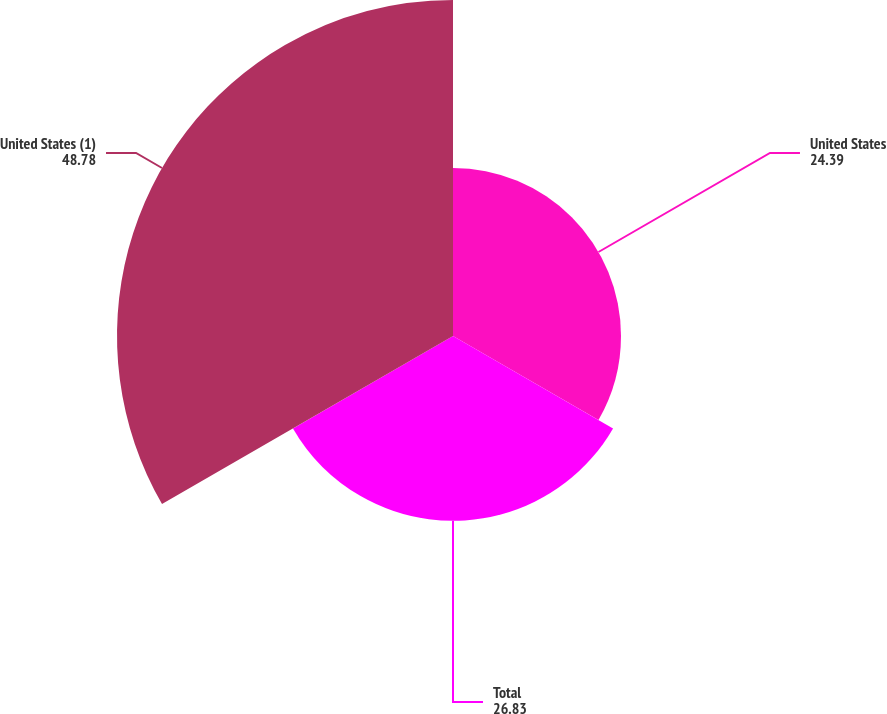Convert chart to OTSL. <chart><loc_0><loc_0><loc_500><loc_500><pie_chart><fcel>United States<fcel>Total<fcel>United States (1)<nl><fcel>24.39%<fcel>26.83%<fcel>48.78%<nl></chart> 